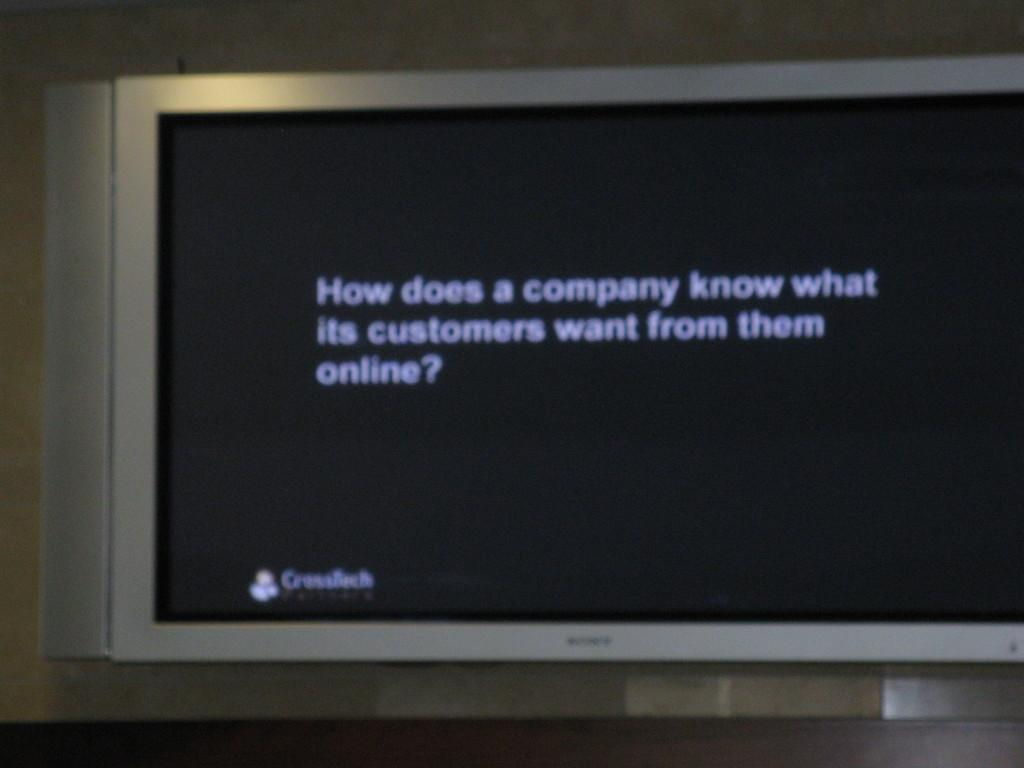<image>
Relay a brief, clear account of the picture shown. a monitor with the words How doe a company know 